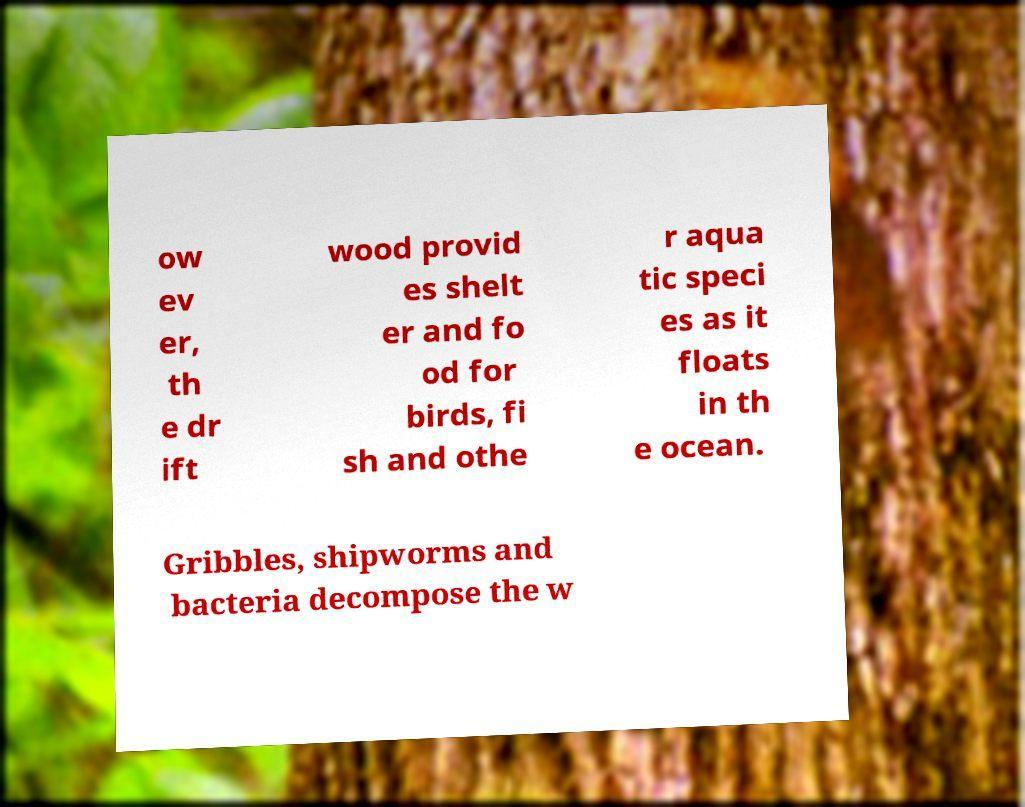Could you extract and type out the text from this image? ow ev er, th e dr ift wood provid es shelt er and fo od for birds, fi sh and othe r aqua tic speci es as it floats in th e ocean. Gribbles, shipworms and bacteria decompose the w 